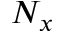Convert formula to latex. <formula><loc_0><loc_0><loc_500><loc_500>N _ { x }</formula> 